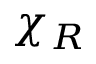Convert formula to latex. <formula><loc_0><loc_0><loc_500><loc_500>\chi _ { R }</formula> 